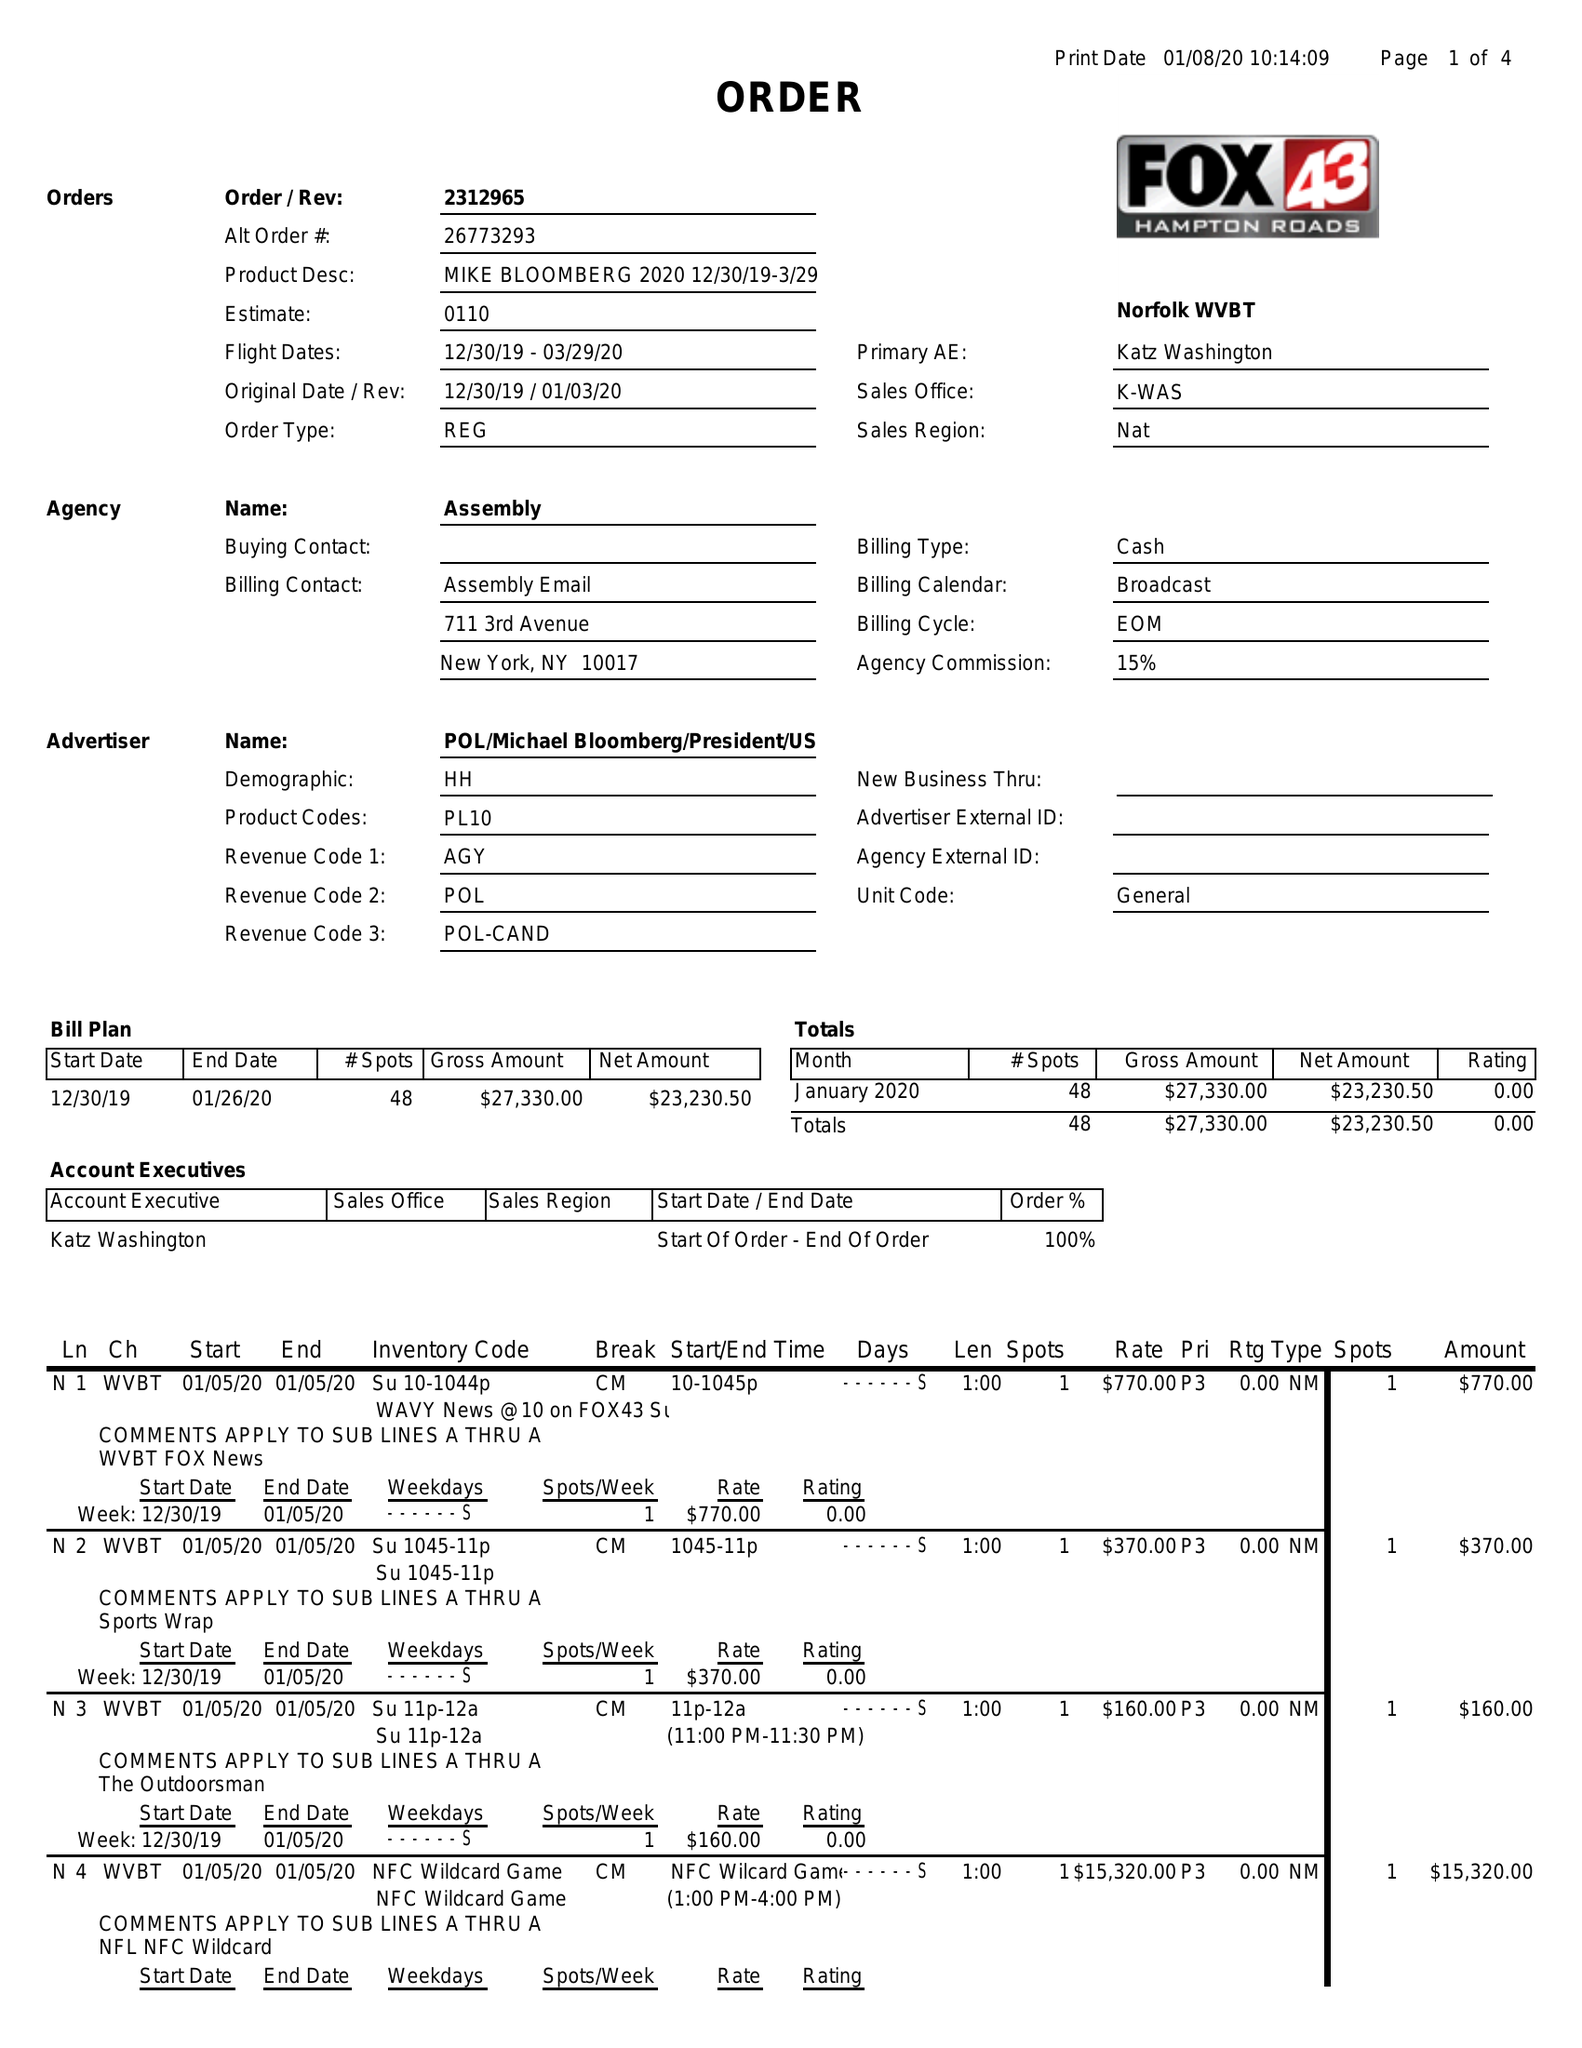What is the value for the flight_from?
Answer the question using a single word or phrase. 12/30/19 